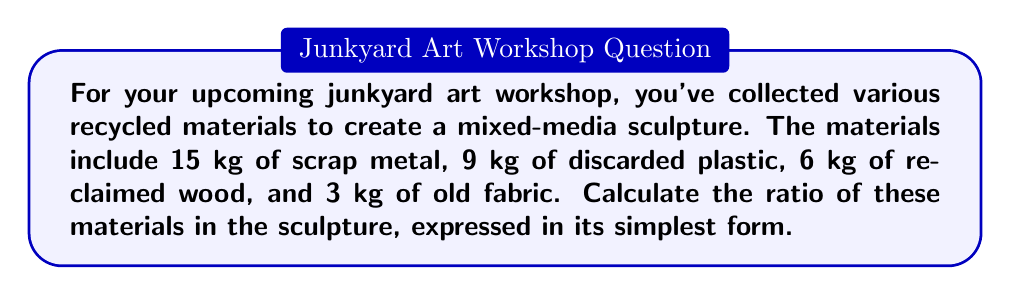Can you solve this math problem? To solve this problem, we need to follow these steps:

1. List all the materials and their weights:
   - Scrap metal: 15 kg
   - Discarded plastic: 9 kg
   - Reclaimed wood: 6 kg
   - Old fabric: 3 kg

2. Write the ratio using the weights in the order given:
   $15 : 9 : 6 : 3$

3. To simplify the ratio, we need to find the greatest common divisor (GCD) of all numbers:
   $GCD(15, 9, 6, 3) = 3$

4. Divide each number in the ratio by the GCD:
   $\frac{15}{3} : \frac{9}{3} : \frac{6}{3} : \frac{3}{3}$

5. Simplify:
   $5 : 3 : 2 : 1$

This simplified ratio represents the proportion of each material in the sculpture, where:
- 5 parts are scrap metal
- 3 parts are discarded plastic
- 2 parts are reclaimed wood
- 1 part is old fabric
Answer: $5 : 3 : 2 : 1$ 